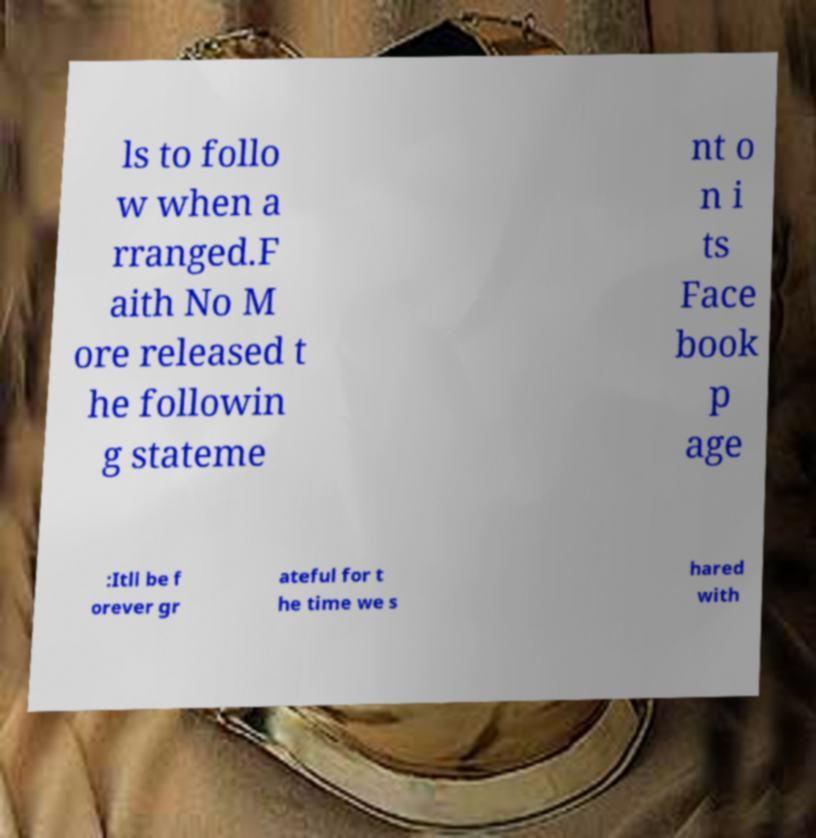There's text embedded in this image that I need extracted. Can you transcribe it verbatim? ls to follo w when a rranged.F aith No M ore released t he followin g stateme nt o n i ts Face book p age :Itll be f orever gr ateful for t he time we s hared with 